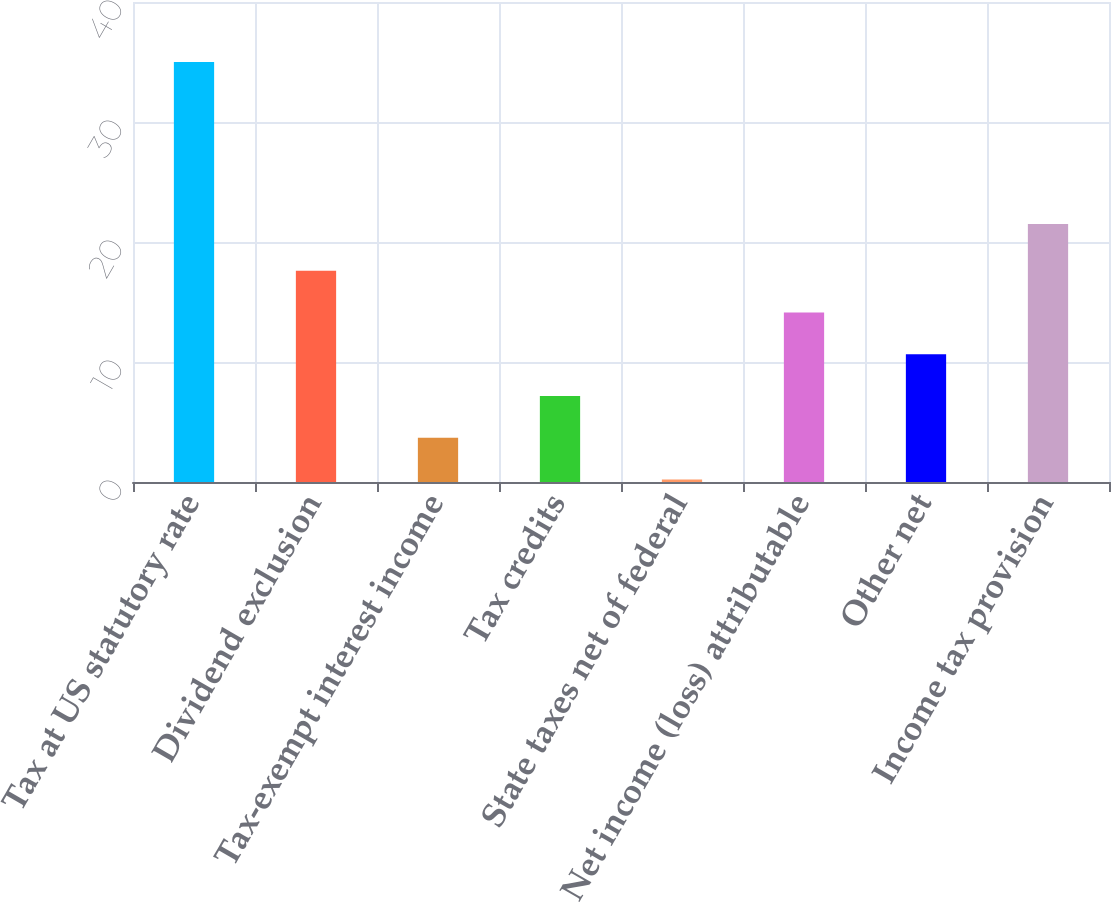<chart> <loc_0><loc_0><loc_500><loc_500><bar_chart><fcel>Tax at US statutory rate<fcel>Dividend exclusion<fcel>Tax-exempt interest income<fcel>Tax credits<fcel>State taxes net of federal<fcel>Net income (loss) attributable<fcel>Other net<fcel>Income tax provision<nl><fcel>35<fcel>17.6<fcel>3.68<fcel>7.16<fcel>0.2<fcel>14.12<fcel>10.64<fcel>21.5<nl></chart> 